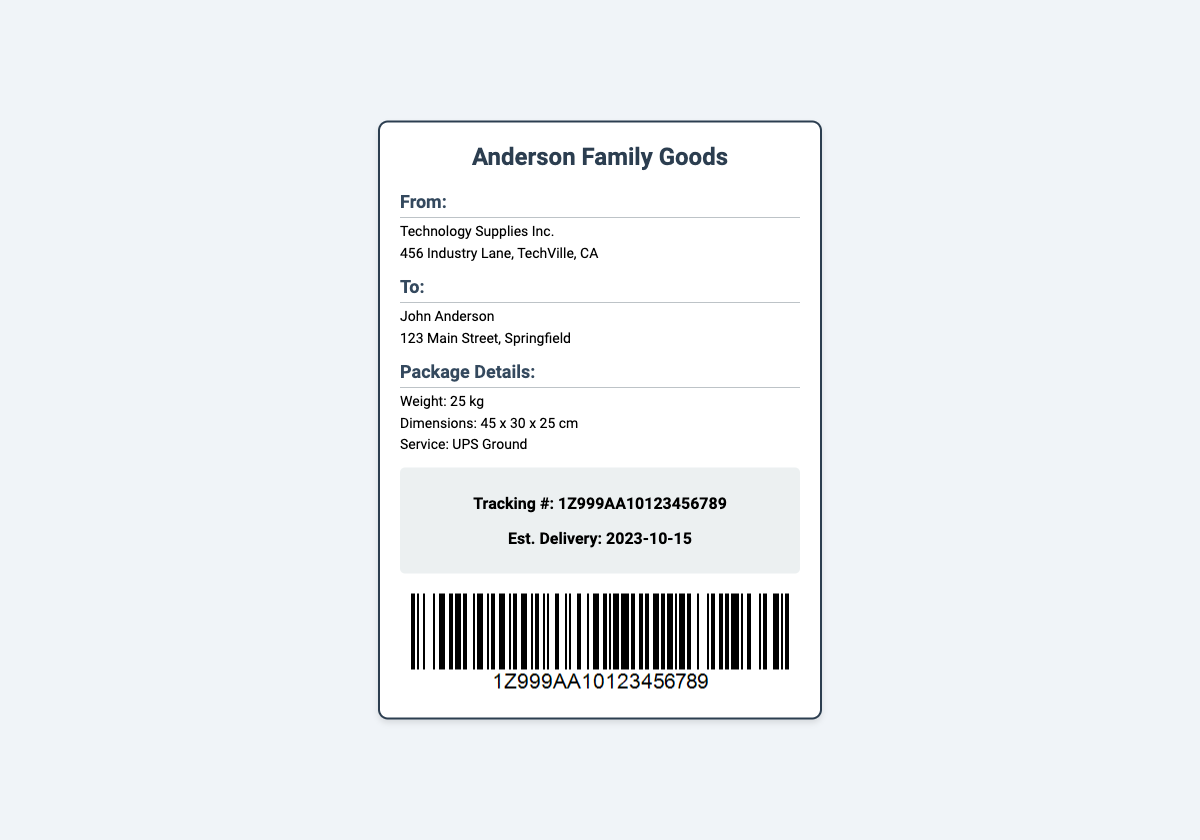What is the sender's name? The sender is listed as "Technology Supplies Inc." in the document.
Answer: Technology Supplies Inc What is the recipient's address? The document provides the full address for the recipient, John Anderson.
Answer: 123 Main Street, Springfield What is the weight of the package? The label states the weight of the package as part of the package details.
Answer: 25 kg What is the estimated delivery date? The estimated delivery date is provided in the tracking section of the document.
Answer: 2023-10-15 What shipping service is used? The shipping service is mentioned under the package details.
Answer: UPS Ground What is the tracking number? The tracking number is specified in the tracking section.
Answer: 1Z999AA10123456789 What are the package dimensions? The package dimensions are included in the package details section.
Answer: 45 x 30 x 25 cm Where is the sender located? The sender's location is listed in the shipping label, specifically providing an address.
Answer: 456 Industry Lane, TechVille, CA What is the primary purpose of this document? This document serves as a shipping label for tracking a shipment.
Answer: Shipping label 